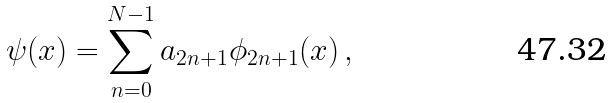Convert formula to latex. <formula><loc_0><loc_0><loc_500><loc_500>\psi ( x ) = \sum _ { n = 0 } ^ { N - 1 } a _ { 2 n + 1 } \phi _ { 2 n + 1 } ( x ) \, ,</formula> 